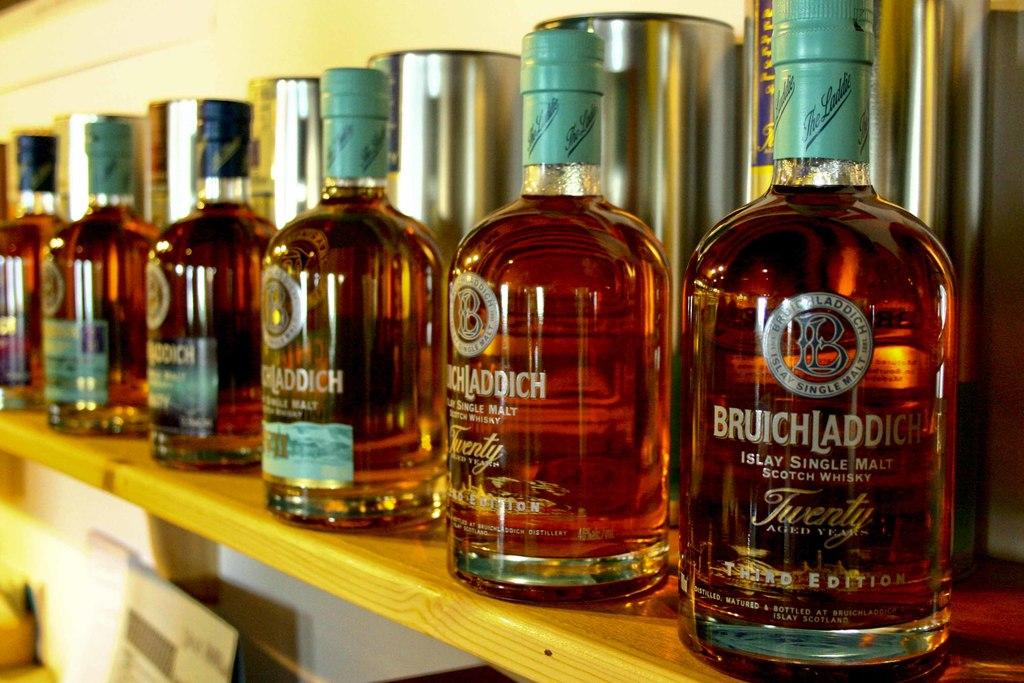<image>
Give a short and clear explanation of the subsequent image. A shelf with bottles Bruichladdick Scotch Whiskey lined up 